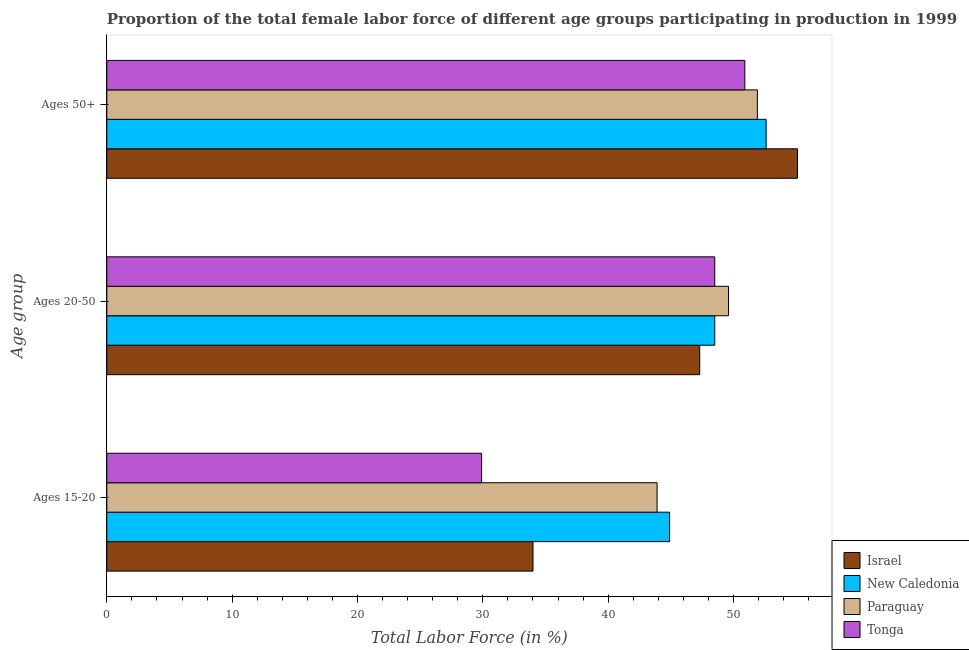How many different coloured bars are there?
Your answer should be compact. 4. How many groups of bars are there?
Make the answer very short. 3. Are the number of bars on each tick of the Y-axis equal?
Your response must be concise. Yes. How many bars are there on the 1st tick from the bottom?
Make the answer very short. 4. What is the label of the 2nd group of bars from the top?
Make the answer very short. Ages 20-50. What is the percentage of female labor force within the age group 15-20 in Tonga?
Your answer should be compact. 29.9. Across all countries, what is the maximum percentage of female labor force above age 50?
Offer a very short reply. 55.1. Across all countries, what is the minimum percentage of female labor force above age 50?
Provide a short and direct response. 50.9. In which country was the percentage of female labor force above age 50 maximum?
Provide a short and direct response. Israel. In which country was the percentage of female labor force above age 50 minimum?
Ensure brevity in your answer.  Tonga. What is the total percentage of female labor force above age 50 in the graph?
Your answer should be compact. 210.5. What is the difference between the percentage of female labor force within the age group 15-20 in New Caledonia and that in Israel?
Your answer should be very brief. 10.9. What is the difference between the percentage of female labor force within the age group 20-50 in Paraguay and the percentage of female labor force above age 50 in New Caledonia?
Ensure brevity in your answer.  -3. What is the average percentage of female labor force within the age group 20-50 per country?
Offer a very short reply. 48.47. What is the difference between the percentage of female labor force within the age group 20-50 and percentage of female labor force within the age group 15-20 in Israel?
Your response must be concise. 13.3. In how many countries, is the percentage of female labor force within the age group 15-20 greater than 46 %?
Offer a terse response. 0. What is the ratio of the percentage of female labor force above age 50 in Tonga to that in Israel?
Provide a short and direct response. 0.92. Is the percentage of female labor force within the age group 15-20 in Israel less than that in Paraguay?
Your response must be concise. Yes. What is the difference between the highest and the second highest percentage of female labor force within the age group 20-50?
Your answer should be compact. 1.1. What is the difference between the highest and the lowest percentage of female labor force within the age group 15-20?
Ensure brevity in your answer.  15. Is the sum of the percentage of female labor force above age 50 in Israel and Tonga greater than the maximum percentage of female labor force within the age group 15-20 across all countries?
Offer a terse response. Yes. What does the 3rd bar from the top in Ages 15-20 represents?
Provide a succinct answer. New Caledonia. What does the 3rd bar from the bottom in Ages 20-50 represents?
Offer a terse response. Paraguay. Is it the case that in every country, the sum of the percentage of female labor force within the age group 15-20 and percentage of female labor force within the age group 20-50 is greater than the percentage of female labor force above age 50?
Provide a succinct answer. Yes. Are all the bars in the graph horizontal?
Keep it short and to the point. Yes. How many countries are there in the graph?
Provide a succinct answer. 4. Does the graph contain any zero values?
Provide a succinct answer. No. Where does the legend appear in the graph?
Your answer should be very brief. Bottom right. How are the legend labels stacked?
Offer a very short reply. Vertical. What is the title of the graph?
Offer a terse response. Proportion of the total female labor force of different age groups participating in production in 1999. Does "New Zealand" appear as one of the legend labels in the graph?
Offer a terse response. No. What is the label or title of the Y-axis?
Provide a short and direct response. Age group. What is the Total Labor Force (in %) of New Caledonia in Ages 15-20?
Offer a very short reply. 44.9. What is the Total Labor Force (in %) in Paraguay in Ages 15-20?
Provide a short and direct response. 43.9. What is the Total Labor Force (in %) in Tonga in Ages 15-20?
Ensure brevity in your answer.  29.9. What is the Total Labor Force (in %) in Israel in Ages 20-50?
Your response must be concise. 47.3. What is the Total Labor Force (in %) in New Caledonia in Ages 20-50?
Your answer should be very brief. 48.5. What is the Total Labor Force (in %) of Paraguay in Ages 20-50?
Ensure brevity in your answer.  49.6. What is the Total Labor Force (in %) in Tonga in Ages 20-50?
Your answer should be very brief. 48.5. What is the Total Labor Force (in %) in Israel in Ages 50+?
Provide a succinct answer. 55.1. What is the Total Labor Force (in %) of New Caledonia in Ages 50+?
Provide a succinct answer. 52.6. What is the Total Labor Force (in %) of Paraguay in Ages 50+?
Your response must be concise. 51.9. What is the Total Labor Force (in %) of Tonga in Ages 50+?
Offer a very short reply. 50.9. Across all Age group, what is the maximum Total Labor Force (in %) of Israel?
Offer a terse response. 55.1. Across all Age group, what is the maximum Total Labor Force (in %) of New Caledonia?
Give a very brief answer. 52.6. Across all Age group, what is the maximum Total Labor Force (in %) in Paraguay?
Offer a terse response. 51.9. Across all Age group, what is the maximum Total Labor Force (in %) in Tonga?
Provide a short and direct response. 50.9. Across all Age group, what is the minimum Total Labor Force (in %) in New Caledonia?
Keep it short and to the point. 44.9. Across all Age group, what is the minimum Total Labor Force (in %) in Paraguay?
Make the answer very short. 43.9. Across all Age group, what is the minimum Total Labor Force (in %) in Tonga?
Give a very brief answer. 29.9. What is the total Total Labor Force (in %) in Israel in the graph?
Your response must be concise. 136.4. What is the total Total Labor Force (in %) in New Caledonia in the graph?
Offer a terse response. 146. What is the total Total Labor Force (in %) in Paraguay in the graph?
Provide a short and direct response. 145.4. What is the total Total Labor Force (in %) of Tonga in the graph?
Your answer should be very brief. 129.3. What is the difference between the Total Labor Force (in %) of Israel in Ages 15-20 and that in Ages 20-50?
Provide a short and direct response. -13.3. What is the difference between the Total Labor Force (in %) in Paraguay in Ages 15-20 and that in Ages 20-50?
Provide a succinct answer. -5.7. What is the difference between the Total Labor Force (in %) of Tonga in Ages 15-20 and that in Ages 20-50?
Your answer should be very brief. -18.6. What is the difference between the Total Labor Force (in %) of Israel in Ages 15-20 and that in Ages 50+?
Ensure brevity in your answer.  -21.1. What is the difference between the Total Labor Force (in %) of New Caledonia in Ages 15-20 and that in Ages 50+?
Ensure brevity in your answer.  -7.7. What is the difference between the Total Labor Force (in %) in Israel in Ages 20-50 and that in Ages 50+?
Offer a very short reply. -7.8. What is the difference between the Total Labor Force (in %) in New Caledonia in Ages 20-50 and that in Ages 50+?
Your answer should be very brief. -4.1. What is the difference between the Total Labor Force (in %) of Paraguay in Ages 20-50 and that in Ages 50+?
Offer a terse response. -2.3. What is the difference between the Total Labor Force (in %) in Tonga in Ages 20-50 and that in Ages 50+?
Ensure brevity in your answer.  -2.4. What is the difference between the Total Labor Force (in %) of Israel in Ages 15-20 and the Total Labor Force (in %) of New Caledonia in Ages 20-50?
Your response must be concise. -14.5. What is the difference between the Total Labor Force (in %) in Israel in Ages 15-20 and the Total Labor Force (in %) in Paraguay in Ages 20-50?
Provide a short and direct response. -15.6. What is the difference between the Total Labor Force (in %) in Israel in Ages 15-20 and the Total Labor Force (in %) in Tonga in Ages 20-50?
Offer a very short reply. -14.5. What is the difference between the Total Labor Force (in %) in Paraguay in Ages 15-20 and the Total Labor Force (in %) in Tonga in Ages 20-50?
Your answer should be compact. -4.6. What is the difference between the Total Labor Force (in %) in Israel in Ages 15-20 and the Total Labor Force (in %) in New Caledonia in Ages 50+?
Keep it short and to the point. -18.6. What is the difference between the Total Labor Force (in %) of Israel in Ages 15-20 and the Total Labor Force (in %) of Paraguay in Ages 50+?
Ensure brevity in your answer.  -17.9. What is the difference between the Total Labor Force (in %) of Israel in Ages 15-20 and the Total Labor Force (in %) of Tonga in Ages 50+?
Offer a very short reply. -16.9. What is the difference between the Total Labor Force (in %) of New Caledonia in Ages 15-20 and the Total Labor Force (in %) of Paraguay in Ages 50+?
Offer a very short reply. -7. What is the difference between the Total Labor Force (in %) in Paraguay in Ages 15-20 and the Total Labor Force (in %) in Tonga in Ages 50+?
Offer a terse response. -7. What is the difference between the Total Labor Force (in %) in Israel in Ages 20-50 and the Total Labor Force (in %) in New Caledonia in Ages 50+?
Your answer should be compact. -5.3. What is the difference between the Total Labor Force (in %) of Israel in Ages 20-50 and the Total Labor Force (in %) of Tonga in Ages 50+?
Your answer should be very brief. -3.6. What is the difference between the Total Labor Force (in %) in New Caledonia in Ages 20-50 and the Total Labor Force (in %) in Tonga in Ages 50+?
Provide a short and direct response. -2.4. What is the average Total Labor Force (in %) in Israel per Age group?
Offer a terse response. 45.47. What is the average Total Labor Force (in %) in New Caledonia per Age group?
Give a very brief answer. 48.67. What is the average Total Labor Force (in %) in Paraguay per Age group?
Make the answer very short. 48.47. What is the average Total Labor Force (in %) of Tonga per Age group?
Your answer should be compact. 43.1. What is the difference between the Total Labor Force (in %) in Israel and Total Labor Force (in %) in New Caledonia in Ages 15-20?
Ensure brevity in your answer.  -10.9. What is the difference between the Total Labor Force (in %) in Israel and Total Labor Force (in %) in Paraguay in Ages 15-20?
Offer a very short reply. -9.9. What is the difference between the Total Labor Force (in %) of Israel and Total Labor Force (in %) of Tonga in Ages 15-20?
Ensure brevity in your answer.  4.1. What is the difference between the Total Labor Force (in %) in New Caledonia and Total Labor Force (in %) in Tonga in Ages 15-20?
Offer a terse response. 15. What is the difference between the Total Labor Force (in %) in Paraguay and Total Labor Force (in %) in Tonga in Ages 15-20?
Provide a succinct answer. 14. What is the difference between the Total Labor Force (in %) in Israel and Total Labor Force (in %) in New Caledonia in Ages 20-50?
Give a very brief answer. -1.2. What is the difference between the Total Labor Force (in %) of New Caledonia and Total Labor Force (in %) of Paraguay in Ages 20-50?
Keep it short and to the point. -1.1. What is the difference between the Total Labor Force (in %) of Israel and Total Labor Force (in %) of New Caledonia in Ages 50+?
Offer a very short reply. 2.5. What is the difference between the Total Labor Force (in %) in Israel and Total Labor Force (in %) in Tonga in Ages 50+?
Provide a succinct answer. 4.2. What is the difference between the Total Labor Force (in %) in New Caledonia and Total Labor Force (in %) in Paraguay in Ages 50+?
Your answer should be compact. 0.7. What is the difference between the Total Labor Force (in %) in Paraguay and Total Labor Force (in %) in Tonga in Ages 50+?
Make the answer very short. 1. What is the ratio of the Total Labor Force (in %) in Israel in Ages 15-20 to that in Ages 20-50?
Make the answer very short. 0.72. What is the ratio of the Total Labor Force (in %) in New Caledonia in Ages 15-20 to that in Ages 20-50?
Make the answer very short. 0.93. What is the ratio of the Total Labor Force (in %) of Paraguay in Ages 15-20 to that in Ages 20-50?
Offer a terse response. 0.89. What is the ratio of the Total Labor Force (in %) of Tonga in Ages 15-20 to that in Ages 20-50?
Provide a succinct answer. 0.62. What is the ratio of the Total Labor Force (in %) of Israel in Ages 15-20 to that in Ages 50+?
Provide a succinct answer. 0.62. What is the ratio of the Total Labor Force (in %) of New Caledonia in Ages 15-20 to that in Ages 50+?
Give a very brief answer. 0.85. What is the ratio of the Total Labor Force (in %) of Paraguay in Ages 15-20 to that in Ages 50+?
Provide a short and direct response. 0.85. What is the ratio of the Total Labor Force (in %) in Tonga in Ages 15-20 to that in Ages 50+?
Give a very brief answer. 0.59. What is the ratio of the Total Labor Force (in %) of Israel in Ages 20-50 to that in Ages 50+?
Offer a terse response. 0.86. What is the ratio of the Total Labor Force (in %) of New Caledonia in Ages 20-50 to that in Ages 50+?
Give a very brief answer. 0.92. What is the ratio of the Total Labor Force (in %) in Paraguay in Ages 20-50 to that in Ages 50+?
Ensure brevity in your answer.  0.96. What is the ratio of the Total Labor Force (in %) in Tonga in Ages 20-50 to that in Ages 50+?
Offer a terse response. 0.95. What is the difference between the highest and the second highest Total Labor Force (in %) in Paraguay?
Provide a short and direct response. 2.3. What is the difference between the highest and the second highest Total Labor Force (in %) of Tonga?
Provide a short and direct response. 2.4. What is the difference between the highest and the lowest Total Labor Force (in %) of Israel?
Give a very brief answer. 21.1. What is the difference between the highest and the lowest Total Labor Force (in %) of New Caledonia?
Your response must be concise. 7.7. 